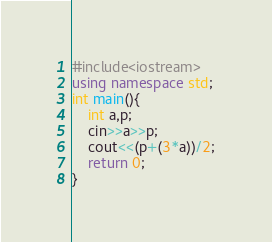<code> <loc_0><loc_0><loc_500><loc_500><_C++_>#include<iostream>
using namespace std;
int main(){
	int a,p;
  	cin>>a>>p;
    cout<<(p+(3*a))/2;
    return 0;
}</code> 